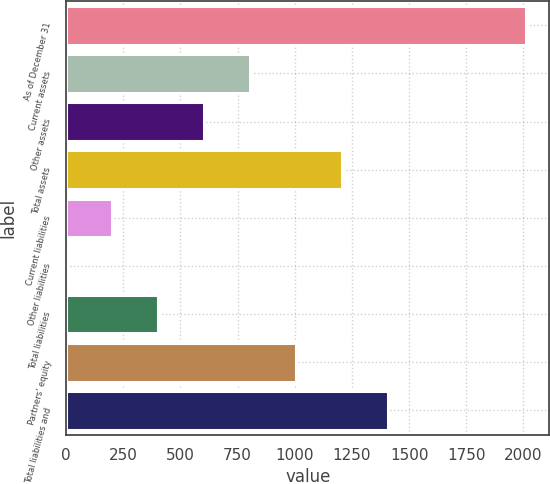<chart> <loc_0><loc_0><loc_500><loc_500><bar_chart><fcel>As of December 31<fcel>Current assets<fcel>Other assets<fcel>Total assets<fcel>Current liabilities<fcel>Other liabilities<fcel>Total liabilities<fcel>Partners' equity<fcel>Total liabilities and<nl><fcel>2013<fcel>805.98<fcel>604.81<fcel>1208.32<fcel>202.47<fcel>1.3<fcel>403.64<fcel>1007.15<fcel>1409.49<nl></chart> 